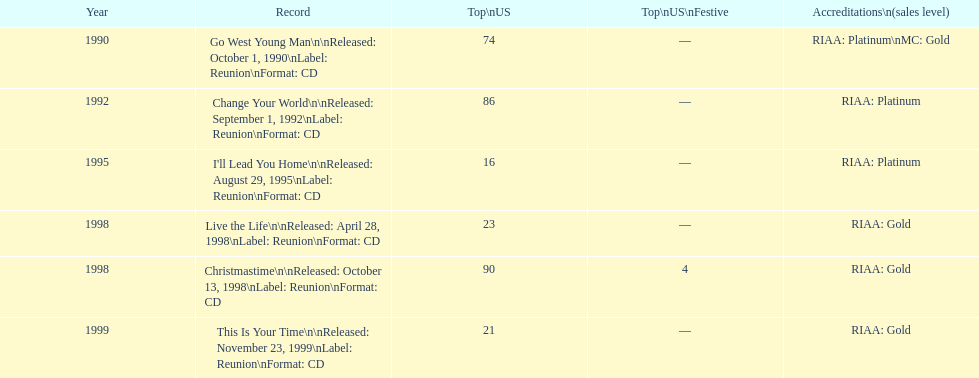Which album has the least peak in the us? I'll Lead You Home. 